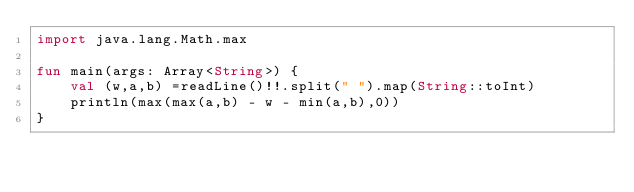<code> <loc_0><loc_0><loc_500><loc_500><_Kotlin_>import java.lang.Math.max

fun main(args: Array<String>) {
    val (w,a,b) =readLine()!!.split(" ").map(String::toInt)
    println(max(max(a,b) - w - min(a,b),0))
}</code> 